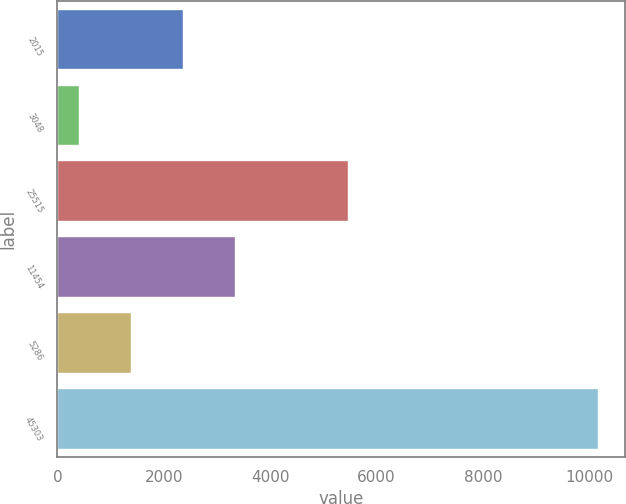<chart> <loc_0><loc_0><loc_500><loc_500><bar_chart><fcel>2015<fcel>3048<fcel>25515<fcel>11454<fcel>5286<fcel>45303<nl><fcel>2358.2<fcel>408<fcel>5464<fcel>3333.3<fcel>1383.1<fcel>10159<nl></chart> 